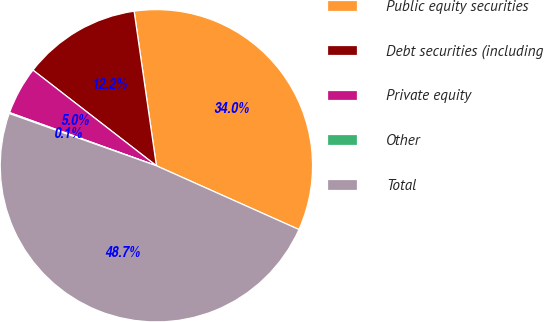Convert chart. <chart><loc_0><loc_0><loc_500><loc_500><pie_chart><fcel>Public equity securities<fcel>Debt securities (including<fcel>Private equity<fcel>Other<fcel>Total<nl><fcel>33.97%<fcel>12.23%<fcel>4.96%<fcel>0.1%<fcel>48.74%<nl></chart> 